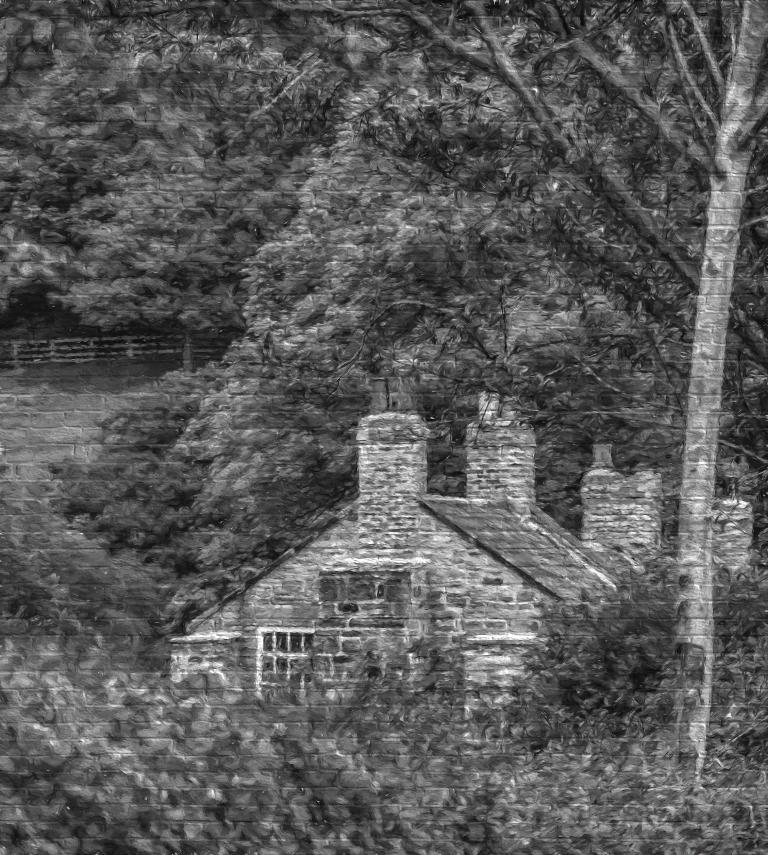What is depicted on the wall in the image? There is a painting on the wall. What elements are included in the painting? The painting contains trees and a house. What type of distribution theory is being discussed in the painting? There is no discussion of distribution theory in the painting; it contains trees and a house. 